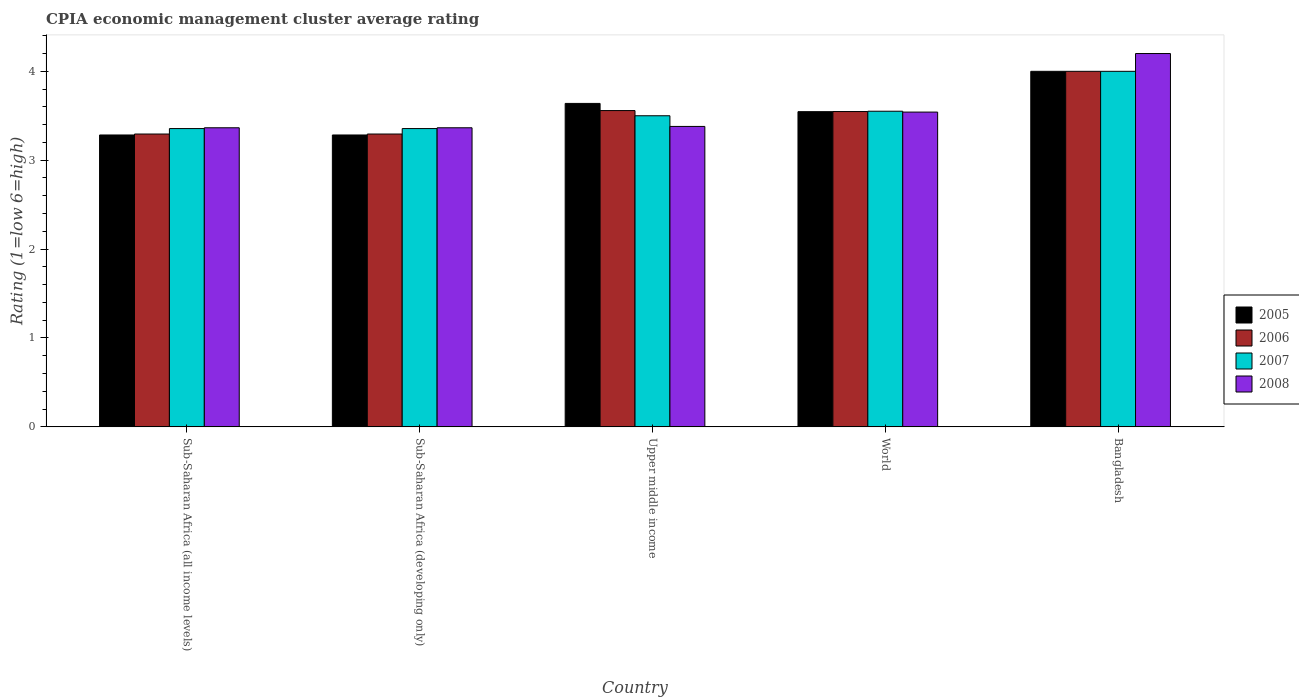How many different coloured bars are there?
Your response must be concise. 4. How many groups of bars are there?
Provide a short and direct response. 5. Are the number of bars per tick equal to the number of legend labels?
Your response must be concise. Yes. What is the CPIA rating in 2006 in Sub-Saharan Africa (developing only)?
Your answer should be compact. 3.29. Across all countries, what is the minimum CPIA rating in 2005?
Offer a very short reply. 3.28. In which country was the CPIA rating in 2007 minimum?
Give a very brief answer. Sub-Saharan Africa (all income levels). What is the total CPIA rating in 2005 in the graph?
Your answer should be compact. 17.75. What is the difference between the CPIA rating in 2005 in Sub-Saharan Africa (all income levels) and that in Upper middle income?
Provide a succinct answer. -0.36. What is the difference between the CPIA rating in 2008 in World and the CPIA rating in 2005 in Bangladesh?
Give a very brief answer. -0.46. What is the average CPIA rating in 2005 per country?
Provide a short and direct response. 3.55. In how many countries, is the CPIA rating in 2007 greater than 4.2?
Offer a terse response. 0. What is the ratio of the CPIA rating in 2005 in Sub-Saharan Africa (developing only) to that in Upper middle income?
Your answer should be very brief. 0.9. Is the CPIA rating in 2007 in Sub-Saharan Africa (all income levels) less than that in Sub-Saharan Africa (developing only)?
Make the answer very short. No. What is the difference between the highest and the second highest CPIA rating in 2008?
Provide a succinct answer. -0.16. What is the difference between the highest and the lowest CPIA rating in 2006?
Your answer should be compact. 0.71. In how many countries, is the CPIA rating in 2007 greater than the average CPIA rating in 2007 taken over all countries?
Your response must be concise. 1. Is it the case that in every country, the sum of the CPIA rating in 2005 and CPIA rating in 2007 is greater than the sum of CPIA rating in 2006 and CPIA rating in 2008?
Offer a very short reply. No. What does the 3rd bar from the right in Bangladesh represents?
Provide a short and direct response. 2006. How many bars are there?
Offer a terse response. 20. Are all the bars in the graph horizontal?
Provide a succinct answer. No. How many countries are there in the graph?
Offer a very short reply. 5. What is the difference between two consecutive major ticks on the Y-axis?
Make the answer very short. 1. Are the values on the major ticks of Y-axis written in scientific E-notation?
Offer a terse response. No. Does the graph contain any zero values?
Your response must be concise. No. Where does the legend appear in the graph?
Make the answer very short. Center right. How many legend labels are there?
Provide a short and direct response. 4. What is the title of the graph?
Ensure brevity in your answer.  CPIA economic management cluster average rating. What is the label or title of the Y-axis?
Provide a succinct answer. Rating (1=low 6=high). What is the Rating (1=low 6=high) in 2005 in Sub-Saharan Africa (all income levels)?
Offer a very short reply. 3.28. What is the Rating (1=low 6=high) in 2006 in Sub-Saharan Africa (all income levels)?
Provide a succinct answer. 3.29. What is the Rating (1=low 6=high) of 2007 in Sub-Saharan Africa (all income levels)?
Provide a short and direct response. 3.36. What is the Rating (1=low 6=high) in 2008 in Sub-Saharan Africa (all income levels)?
Your answer should be very brief. 3.36. What is the Rating (1=low 6=high) in 2005 in Sub-Saharan Africa (developing only)?
Make the answer very short. 3.28. What is the Rating (1=low 6=high) in 2006 in Sub-Saharan Africa (developing only)?
Make the answer very short. 3.29. What is the Rating (1=low 6=high) in 2007 in Sub-Saharan Africa (developing only)?
Ensure brevity in your answer.  3.36. What is the Rating (1=low 6=high) in 2008 in Sub-Saharan Africa (developing only)?
Offer a terse response. 3.36. What is the Rating (1=low 6=high) in 2005 in Upper middle income?
Provide a short and direct response. 3.64. What is the Rating (1=low 6=high) of 2006 in Upper middle income?
Ensure brevity in your answer.  3.56. What is the Rating (1=low 6=high) of 2008 in Upper middle income?
Give a very brief answer. 3.38. What is the Rating (1=low 6=high) of 2005 in World?
Ensure brevity in your answer.  3.55. What is the Rating (1=low 6=high) in 2006 in World?
Provide a succinct answer. 3.55. What is the Rating (1=low 6=high) of 2007 in World?
Ensure brevity in your answer.  3.55. What is the Rating (1=low 6=high) in 2008 in World?
Your response must be concise. 3.54. Across all countries, what is the maximum Rating (1=low 6=high) of 2005?
Ensure brevity in your answer.  4. Across all countries, what is the maximum Rating (1=low 6=high) in 2007?
Offer a very short reply. 4. Across all countries, what is the minimum Rating (1=low 6=high) of 2005?
Offer a very short reply. 3.28. Across all countries, what is the minimum Rating (1=low 6=high) of 2006?
Offer a terse response. 3.29. Across all countries, what is the minimum Rating (1=low 6=high) in 2007?
Provide a succinct answer. 3.36. Across all countries, what is the minimum Rating (1=low 6=high) in 2008?
Keep it short and to the point. 3.36. What is the total Rating (1=low 6=high) in 2005 in the graph?
Provide a short and direct response. 17.75. What is the total Rating (1=low 6=high) in 2006 in the graph?
Give a very brief answer. 17.7. What is the total Rating (1=low 6=high) of 2007 in the graph?
Your answer should be very brief. 17.76. What is the total Rating (1=low 6=high) of 2008 in the graph?
Offer a very short reply. 17.85. What is the difference between the Rating (1=low 6=high) of 2006 in Sub-Saharan Africa (all income levels) and that in Sub-Saharan Africa (developing only)?
Keep it short and to the point. 0. What is the difference between the Rating (1=low 6=high) of 2008 in Sub-Saharan Africa (all income levels) and that in Sub-Saharan Africa (developing only)?
Offer a terse response. 0. What is the difference between the Rating (1=low 6=high) in 2005 in Sub-Saharan Africa (all income levels) and that in Upper middle income?
Provide a short and direct response. -0.36. What is the difference between the Rating (1=low 6=high) in 2006 in Sub-Saharan Africa (all income levels) and that in Upper middle income?
Your answer should be very brief. -0.26. What is the difference between the Rating (1=low 6=high) of 2007 in Sub-Saharan Africa (all income levels) and that in Upper middle income?
Ensure brevity in your answer.  -0.14. What is the difference between the Rating (1=low 6=high) in 2008 in Sub-Saharan Africa (all income levels) and that in Upper middle income?
Your answer should be compact. -0.02. What is the difference between the Rating (1=low 6=high) of 2005 in Sub-Saharan Africa (all income levels) and that in World?
Give a very brief answer. -0.26. What is the difference between the Rating (1=low 6=high) of 2006 in Sub-Saharan Africa (all income levels) and that in World?
Your answer should be compact. -0.25. What is the difference between the Rating (1=low 6=high) of 2007 in Sub-Saharan Africa (all income levels) and that in World?
Keep it short and to the point. -0.2. What is the difference between the Rating (1=low 6=high) in 2008 in Sub-Saharan Africa (all income levels) and that in World?
Ensure brevity in your answer.  -0.18. What is the difference between the Rating (1=low 6=high) in 2005 in Sub-Saharan Africa (all income levels) and that in Bangladesh?
Provide a short and direct response. -0.72. What is the difference between the Rating (1=low 6=high) in 2006 in Sub-Saharan Africa (all income levels) and that in Bangladesh?
Give a very brief answer. -0.71. What is the difference between the Rating (1=low 6=high) in 2007 in Sub-Saharan Africa (all income levels) and that in Bangladesh?
Your response must be concise. -0.64. What is the difference between the Rating (1=low 6=high) in 2008 in Sub-Saharan Africa (all income levels) and that in Bangladesh?
Offer a very short reply. -0.84. What is the difference between the Rating (1=low 6=high) in 2005 in Sub-Saharan Africa (developing only) and that in Upper middle income?
Provide a short and direct response. -0.36. What is the difference between the Rating (1=low 6=high) in 2006 in Sub-Saharan Africa (developing only) and that in Upper middle income?
Give a very brief answer. -0.26. What is the difference between the Rating (1=low 6=high) in 2007 in Sub-Saharan Africa (developing only) and that in Upper middle income?
Make the answer very short. -0.14. What is the difference between the Rating (1=low 6=high) of 2008 in Sub-Saharan Africa (developing only) and that in Upper middle income?
Give a very brief answer. -0.02. What is the difference between the Rating (1=low 6=high) in 2005 in Sub-Saharan Africa (developing only) and that in World?
Make the answer very short. -0.26. What is the difference between the Rating (1=low 6=high) of 2006 in Sub-Saharan Africa (developing only) and that in World?
Offer a very short reply. -0.25. What is the difference between the Rating (1=low 6=high) in 2007 in Sub-Saharan Africa (developing only) and that in World?
Provide a short and direct response. -0.2. What is the difference between the Rating (1=low 6=high) in 2008 in Sub-Saharan Africa (developing only) and that in World?
Provide a short and direct response. -0.18. What is the difference between the Rating (1=low 6=high) in 2005 in Sub-Saharan Africa (developing only) and that in Bangladesh?
Give a very brief answer. -0.72. What is the difference between the Rating (1=low 6=high) in 2006 in Sub-Saharan Africa (developing only) and that in Bangladesh?
Give a very brief answer. -0.71. What is the difference between the Rating (1=low 6=high) in 2007 in Sub-Saharan Africa (developing only) and that in Bangladesh?
Offer a very short reply. -0.64. What is the difference between the Rating (1=low 6=high) in 2008 in Sub-Saharan Africa (developing only) and that in Bangladesh?
Give a very brief answer. -0.84. What is the difference between the Rating (1=low 6=high) in 2005 in Upper middle income and that in World?
Offer a terse response. 0.09. What is the difference between the Rating (1=low 6=high) of 2006 in Upper middle income and that in World?
Your answer should be very brief. 0.01. What is the difference between the Rating (1=low 6=high) in 2007 in Upper middle income and that in World?
Your response must be concise. -0.05. What is the difference between the Rating (1=low 6=high) in 2008 in Upper middle income and that in World?
Make the answer very short. -0.16. What is the difference between the Rating (1=low 6=high) of 2005 in Upper middle income and that in Bangladesh?
Your response must be concise. -0.36. What is the difference between the Rating (1=low 6=high) of 2006 in Upper middle income and that in Bangladesh?
Give a very brief answer. -0.44. What is the difference between the Rating (1=low 6=high) in 2008 in Upper middle income and that in Bangladesh?
Ensure brevity in your answer.  -0.82. What is the difference between the Rating (1=low 6=high) in 2005 in World and that in Bangladesh?
Provide a short and direct response. -0.45. What is the difference between the Rating (1=low 6=high) of 2006 in World and that in Bangladesh?
Give a very brief answer. -0.45. What is the difference between the Rating (1=low 6=high) of 2007 in World and that in Bangladesh?
Provide a short and direct response. -0.45. What is the difference between the Rating (1=low 6=high) in 2008 in World and that in Bangladesh?
Your response must be concise. -0.66. What is the difference between the Rating (1=low 6=high) in 2005 in Sub-Saharan Africa (all income levels) and the Rating (1=low 6=high) in 2006 in Sub-Saharan Africa (developing only)?
Your answer should be very brief. -0.01. What is the difference between the Rating (1=low 6=high) in 2005 in Sub-Saharan Africa (all income levels) and the Rating (1=low 6=high) in 2007 in Sub-Saharan Africa (developing only)?
Your answer should be very brief. -0.07. What is the difference between the Rating (1=low 6=high) in 2005 in Sub-Saharan Africa (all income levels) and the Rating (1=low 6=high) in 2008 in Sub-Saharan Africa (developing only)?
Your response must be concise. -0.08. What is the difference between the Rating (1=low 6=high) in 2006 in Sub-Saharan Africa (all income levels) and the Rating (1=low 6=high) in 2007 in Sub-Saharan Africa (developing only)?
Give a very brief answer. -0.06. What is the difference between the Rating (1=low 6=high) in 2006 in Sub-Saharan Africa (all income levels) and the Rating (1=low 6=high) in 2008 in Sub-Saharan Africa (developing only)?
Provide a succinct answer. -0.07. What is the difference between the Rating (1=low 6=high) of 2007 in Sub-Saharan Africa (all income levels) and the Rating (1=low 6=high) of 2008 in Sub-Saharan Africa (developing only)?
Make the answer very short. -0.01. What is the difference between the Rating (1=low 6=high) of 2005 in Sub-Saharan Africa (all income levels) and the Rating (1=low 6=high) of 2006 in Upper middle income?
Offer a very short reply. -0.27. What is the difference between the Rating (1=low 6=high) of 2005 in Sub-Saharan Africa (all income levels) and the Rating (1=low 6=high) of 2007 in Upper middle income?
Your response must be concise. -0.22. What is the difference between the Rating (1=low 6=high) of 2005 in Sub-Saharan Africa (all income levels) and the Rating (1=low 6=high) of 2008 in Upper middle income?
Provide a succinct answer. -0.1. What is the difference between the Rating (1=low 6=high) of 2006 in Sub-Saharan Africa (all income levels) and the Rating (1=low 6=high) of 2007 in Upper middle income?
Offer a very short reply. -0.21. What is the difference between the Rating (1=low 6=high) of 2006 in Sub-Saharan Africa (all income levels) and the Rating (1=low 6=high) of 2008 in Upper middle income?
Offer a terse response. -0.09. What is the difference between the Rating (1=low 6=high) in 2007 in Sub-Saharan Africa (all income levels) and the Rating (1=low 6=high) in 2008 in Upper middle income?
Keep it short and to the point. -0.02. What is the difference between the Rating (1=low 6=high) of 2005 in Sub-Saharan Africa (all income levels) and the Rating (1=low 6=high) of 2006 in World?
Your answer should be compact. -0.26. What is the difference between the Rating (1=low 6=high) of 2005 in Sub-Saharan Africa (all income levels) and the Rating (1=low 6=high) of 2007 in World?
Make the answer very short. -0.27. What is the difference between the Rating (1=low 6=high) of 2005 in Sub-Saharan Africa (all income levels) and the Rating (1=low 6=high) of 2008 in World?
Ensure brevity in your answer.  -0.26. What is the difference between the Rating (1=low 6=high) in 2006 in Sub-Saharan Africa (all income levels) and the Rating (1=low 6=high) in 2007 in World?
Ensure brevity in your answer.  -0.26. What is the difference between the Rating (1=low 6=high) in 2006 in Sub-Saharan Africa (all income levels) and the Rating (1=low 6=high) in 2008 in World?
Make the answer very short. -0.25. What is the difference between the Rating (1=low 6=high) of 2007 in Sub-Saharan Africa (all income levels) and the Rating (1=low 6=high) of 2008 in World?
Make the answer very short. -0.19. What is the difference between the Rating (1=low 6=high) in 2005 in Sub-Saharan Africa (all income levels) and the Rating (1=low 6=high) in 2006 in Bangladesh?
Your response must be concise. -0.72. What is the difference between the Rating (1=low 6=high) in 2005 in Sub-Saharan Africa (all income levels) and the Rating (1=low 6=high) in 2007 in Bangladesh?
Your answer should be compact. -0.72. What is the difference between the Rating (1=low 6=high) of 2005 in Sub-Saharan Africa (all income levels) and the Rating (1=low 6=high) of 2008 in Bangladesh?
Keep it short and to the point. -0.92. What is the difference between the Rating (1=low 6=high) in 2006 in Sub-Saharan Africa (all income levels) and the Rating (1=low 6=high) in 2007 in Bangladesh?
Provide a succinct answer. -0.71. What is the difference between the Rating (1=low 6=high) in 2006 in Sub-Saharan Africa (all income levels) and the Rating (1=low 6=high) in 2008 in Bangladesh?
Keep it short and to the point. -0.91. What is the difference between the Rating (1=low 6=high) in 2007 in Sub-Saharan Africa (all income levels) and the Rating (1=low 6=high) in 2008 in Bangladesh?
Keep it short and to the point. -0.84. What is the difference between the Rating (1=low 6=high) in 2005 in Sub-Saharan Africa (developing only) and the Rating (1=low 6=high) in 2006 in Upper middle income?
Ensure brevity in your answer.  -0.27. What is the difference between the Rating (1=low 6=high) in 2005 in Sub-Saharan Africa (developing only) and the Rating (1=low 6=high) in 2007 in Upper middle income?
Give a very brief answer. -0.22. What is the difference between the Rating (1=low 6=high) of 2005 in Sub-Saharan Africa (developing only) and the Rating (1=low 6=high) of 2008 in Upper middle income?
Give a very brief answer. -0.1. What is the difference between the Rating (1=low 6=high) in 2006 in Sub-Saharan Africa (developing only) and the Rating (1=low 6=high) in 2007 in Upper middle income?
Your answer should be compact. -0.21. What is the difference between the Rating (1=low 6=high) in 2006 in Sub-Saharan Africa (developing only) and the Rating (1=low 6=high) in 2008 in Upper middle income?
Your response must be concise. -0.09. What is the difference between the Rating (1=low 6=high) in 2007 in Sub-Saharan Africa (developing only) and the Rating (1=low 6=high) in 2008 in Upper middle income?
Ensure brevity in your answer.  -0.02. What is the difference between the Rating (1=low 6=high) of 2005 in Sub-Saharan Africa (developing only) and the Rating (1=low 6=high) of 2006 in World?
Offer a very short reply. -0.26. What is the difference between the Rating (1=low 6=high) of 2005 in Sub-Saharan Africa (developing only) and the Rating (1=low 6=high) of 2007 in World?
Make the answer very short. -0.27. What is the difference between the Rating (1=low 6=high) in 2005 in Sub-Saharan Africa (developing only) and the Rating (1=low 6=high) in 2008 in World?
Offer a very short reply. -0.26. What is the difference between the Rating (1=low 6=high) in 2006 in Sub-Saharan Africa (developing only) and the Rating (1=low 6=high) in 2007 in World?
Your answer should be very brief. -0.26. What is the difference between the Rating (1=low 6=high) in 2006 in Sub-Saharan Africa (developing only) and the Rating (1=low 6=high) in 2008 in World?
Your response must be concise. -0.25. What is the difference between the Rating (1=low 6=high) of 2007 in Sub-Saharan Africa (developing only) and the Rating (1=low 6=high) of 2008 in World?
Your answer should be compact. -0.19. What is the difference between the Rating (1=low 6=high) in 2005 in Sub-Saharan Africa (developing only) and the Rating (1=low 6=high) in 2006 in Bangladesh?
Offer a very short reply. -0.72. What is the difference between the Rating (1=low 6=high) in 2005 in Sub-Saharan Africa (developing only) and the Rating (1=low 6=high) in 2007 in Bangladesh?
Ensure brevity in your answer.  -0.72. What is the difference between the Rating (1=low 6=high) in 2005 in Sub-Saharan Africa (developing only) and the Rating (1=low 6=high) in 2008 in Bangladesh?
Your answer should be compact. -0.92. What is the difference between the Rating (1=low 6=high) in 2006 in Sub-Saharan Africa (developing only) and the Rating (1=low 6=high) in 2007 in Bangladesh?
Ensure brevity in your answer.  -0.71. What is the difference between the Rating (1=low 6=high) of 2006 in Sub-Saharan Africa (developing only) and the Rating (1=low 6=high) of 2008 in Bangladesh?
Your response must be concise. -0.91. What is the difference between the Rating (1=low 6=high) in 2007 in Sub-Saharan Africa (developing only) and the Rating (1=low 6=high) in 2008 in Bangladesh?
Provide a short and direct response. -0.84. What is the difference between the Rating (1=low 6=high) in 2005 in Upper middle income and the Rating (1=low 6=high) in 2006 in World?
Make the answer very short. 0.09. What is the difference between the Rating (1=low 6=high) in 2005 in Upper middle income and the Rating (1=low 6=high) in 2007 in World?
Offer a very short reply. 0.09. What is the difference between the Rating (1=low 6=high) in 2005 in Upper middle income and the Rating (1=low 6=high) in 2008 in World?
Keep it short and to the point. 0.1. What is the difference between the Rating (1=low 6=high) in 2006 in Upper middle income and the Rating (1=low 6=high) in 2007 in World?
Offer a very short reply. 0.01. What is the difference between the Rating (1=low 6=high) in 2006 in Upper middle income and the Rating (1=low 6=high) in 2008 in World?
Your answer should be compact. 0.02. What is the difference between the Rating (1=low 6=high) in 2007 in Upper middle income and the Rating (1=low 6=high) in 2008 in World?
Ensure brevity in your answer.  -0.04. What is the difference between the Rating (1=low 6=high) of 2005 in Upper middle income and the Rating (1=low 6=high) of 2006 in Bangladesh?
Ensure brevity in your answer.  -0.36. What is the difference between the Rating (1=low 6=high) in 2005 in Upper middle income and the Rating (1=low 6=high) in 2007 in Bangladesh?
Your answer should be very brief. -0.36. What is the difference between the Rating (1=low 6=high) in 2005 in Upper middle income and the Rating (1=low 6=high) in 2008 in Bangladesh?
Keep it short and to the point. -0.56. What is the difference between the Rating (1=low 6=high) in 2006 in Upper middle income and the Rating (1=low 6=high) in 2007 in Bangladesh?
Give a very brief answer. -0.44. What is the difference between the Rating (1=low 6=high) of 2006 in Upper middle income and the Rating (1=low 6=high) of 2008 in Bangladesh?
Your answer should be compact. -0.64. What is the difference between the Rating (1=low 6=high) of 2007 in Upper middle income and the Rating (1=low 6=high) of 2008 in Bangladesh?
Your answer should be compact. -0.7. What is the difference between the Rating (1=low 6=high) in 2005 in World and the Rating (1=low 6=high) in 2006 in Bangladesh?
Your answer should be very brief. -0.45. What is the difference between the Rating (1=low 6=high) of 2005 in World and the Rating (1=low 6=high) of 2007 in Bangladesh?
Your answer should be compact. -0.45. What is the difference between the Rating (1=low 6=high) in 2005 in World and the Rating (1=low 6=high) in 2008 in Bangladesh?
Offer a very short reply. -0.65. What is the difference between the Rating (1=low 6=high) of 2006 in World and the Rating (1=low 6=high) of 2007 in Bangladesh?
Ensure brevity in your answer.  -0.45. What is the difference between the Rating (1=low 6=high) of 2006 in World and the Rating (1=low 6=high) of 2008 in Bangladesh?
Provide a succinct answer. -0.65. What is the difference between the Rating (1=low 6=high) in 2007 in World and the Rating (1=low 6=high) in 2008 in Bangladesh?
Offer a very short reply. -0.65. What is the average Rating (1=low 6=high) in 2005 per country?
Your answer should be compact. 3.55. What is the average Rating (1=low 6=high) of 2006 per country?
Keep it short and to the point. 3.54. What is the average Rating (1=low 6=high) of 2007 per country?
Make the answer very short. 3.55. What is the average Rating (1=low 6=high) of 2008 per country?
Provide a succinct answer. 3.57. What is the difference between the Rating (1=low 6=high) in 2005 and Rating (1=low 6=high) in 2006 in Sub-Saharan Africa (all income levels)?
Make the answer very short. -0.01. What is the difference between the Rating (1=low 6=high) in 2005 and Rating (1=low 6=high) in 2007 in Sub-Saharan Africa (all income levels)?
Give a very brief answer. -0.07. What is the difference between the Rating (1=low 6=high) of 2005 and Rating (1=low 6=high) of 2008 in Sub-Saharan Africa (all income levels)?
Provide a short and direct response. -0.08. What is the difference between the Rating (1=low 6=high) of 2006 and Rating (1=low 6=high) of 2007 in Sub-Saharan Africa (all income levels)?
Keep it short and to the point. -0.06. What is the difference between the Rating (1=low 6=high) in 2006 and Rating (1=low 6=high) in 2008 in Sub-Saharan Africa (all income levels)?
Provide a succinct answer. -0.07. What is the difference between the Rating (1=low 6=high) of 2007 and Rating (1=low 6=high) of 2008 in Sub-Saharan Africa (all income levels)?
Your answer should be very brief. -0.01. What is the difference between the Rating (1=low 6=high) of 2005 and Rating (1=low 6=high) of 2006 in Sub-Saharan Africa (developing only)?
Provide a succinct answer. -0.01. What is the difference between the Rating (1=low 6=high) in 2005 and Rating (1=low 6=high) in 2007 in Sub-Saharan Africa (developing only)?
Provide a short and direct response. -0.07. What is the difference between the Rating (1=low 6=high) in 2005 and Rating (1=low 6=high) in 2008 in Sub-Saharan Africa (developing only)?
Give a very brief answer. -0.08. What is the difference between the Rating (1=low 6=high) of 2006 and Rating (1=low 6=high) of 2007 in Sub-Saharan Africa (developing only)?
Offer a very short reply. -0.06. What is the difference between the Rating (1=low 6=high) of 2006 and Rating (1=low 6=high) of 2008 in Sub-Saharan Africa (developing only)?
Make the answer very short. -0.07. What is the difference between the Rating (1=low 6=high) of 2007 and Rating (1=low 6=high) of 2008 in Sub-Saharan Africa (developing only)?
Your response must be concise. -0.01. What is the difference between the Rating (1=low 6=high) of 2005 and Rating (1=low 6=high) of 2006 in Upper middle income?
Provide a short and direct response. 0.08. What is the difference between the Rating (1=low 6=high) in 2005 and Rating (1=low 6=high) in 2007 in Upper middle income?
Provide a short and direct response. 0.14. What is the difference between the Rating (1=low 6=high) in 2005 and Rating (1=low 6=high) in 2008 in Upper middle income?
Your answer should be compact. 0.26. What is the difference between the Rating (1=low 6=high) of 2006 and Rating (1=low 6=high) of 2007 in Upper middle income?
Ensure brevity in your answer.  0.06. What is the difference between the Rating (1=low 6=high) in 2006 and Rating (1=low 6=high) in 2008 in Upper middle income?
Make the answer very short. 0.18. What is the difference between the Rating (1=low 6=high) of 2007 and Rating (1=low 6=high) of 2008 in Upper middle income?
Offer a very short reply. 0.12. What is the difference between the Rating (1=low 6=high) in 2005 and Rating (1=low 6=high) in 2006 in World?
Offer a very short reply. -0. What is the difference between the Rating (1=low 6=high) of 2005 and Rating (1=low 6=high) of 2007 in World?
Provide a short and direct response. -0.01. What is the difference between the Rating (1=low 6=high) of 2005 and Rating (1=low 6=high) of 2008 in World?
Your answer should be compact. 0. What is the difference between the Rating (1=low 6=high) in 2006 and Rating (1=low 6=high) in 2007 in World?
Your response must be concise. -0. What is the difference between the Rating (1=low 6=high) in 2006 and Rating (1=low 6=high) in 2008 in World?
Provide a short and direct response. 0.01. What is the difference between the Rating (1=low 6=high) of 2007 and Rating (1=low 6=high) of 2008 in World?
Keep it short and to the point. 0.01. What is the difference between the Rating (1=low 6=high) of 2005 and Rating (1=low 6=high) of 2008 in Bangladesh?
Your response must be concise. -0.2. What is the difference between the Rating (1=low 6=high) in 2006 and Rating (1=low 6=high) in 2008 in Bangladesh?
Keep it short and to the point. -0.2. What is the ratio of the Rating (1=low 6=high) in 2005 in Sub-Saharan Africa (all income levels) to that in Sub-Saharan Africa (developing only)?
Make the answer very short. 1. What is the ratio of the Rating (1=low 6=high) of 2007 in Sub-Saharan Africa (all income levels) to that in Sub-Saharan Africa (developing only)?
Make the answer very short. 1. What is the ratio of the Rating (1=low 6=high) in 2005 in Sub-Saharan Africa (all income levels) to that in Upper middle income?
Your answer should be very brief. 0.9. What is the ratio of the Rating (1=low 6=high) in 2006 in Sub-Saharan Africa (all income levels) to that in Upper middle income?
Make the answer very short. 0.93. What is the ratio of the Rating (1=low 6=high) of 2007 in Sub-Saharan Africa (all income levels) to that in Upper middle income?
Provide a short and direct response. 0.96. What is the ratio of the Rating (1=low 6=high) in 2008 in Sub-Saharan Africa (all income levels) to that in Upper middle income?
Ensure brevity in your answer.  1. What is the ratio of the Rating (1=low 6=high) of 2005 in Sub-Saharan Africa (all income levels) to that in World?
Provide a succinct answer. 0.93. What is the ratio of the Rating (1=low 6=high) in 2006 in Sub-Saharan Africa (all income levels) to that in World?
Offer a terse response. 0.93. What is the ratio of the Rating (1=low 6=high) of 2007 in Sub-Saharan Africa (all income levels) to that in World?
Provide a short and direct response. 0.94. What is the ratio of the Rating (1=low 6=high) in 2008 in Sub-Saharan Africa (all income levels) to that in World?
Offer a very short reply. 0.95. What is the ratio of the Rating (1=low 6=high) of 2005 in Sub-Saharan Africa (all income levels) to that in Bangladesh?
Give a very brief answer. 0.82. What is the ratio of the Rating (1=low 6=high) in 2006 in Sub-Saharan Africa (all income levels) to that in Bangladesh?
Your answer should be compact. 0.82. What is the ratio of the Rating (1=low 6=high) of 2007 in Sub-Saharan Africa (all income levels) to that in Bangladesh?
Ensure brevity in your answer.  0.84. What is the ratio of the Rating (1=low 6=high) of 2008 in Sub-Saharan Africa (all income levels) to that in Bangladesh?
Provide a succinct answer. 0.8. What is the ratio of the Rating (1=low 6=high) in 2005 in Sub-Saharan Africa (developing only) to that in Upper middle income?
Your response must be concise. 0.9. What is the ratio of the Rating (1=low 6=high) in 2006 in Sub-Saharan Africa (developing only) to that in Upper middle income?
Provide a short and direct response. 0.93. What is the ratio of the Rating (1=low 6=high) of 2007 in Sub-Saharan Africa (developing only) to that in Upper middle income?
Offer a terse response. 0.96. What is the ratio of the Rating (1=low 6=high) in 2005 in Sub-Saharan Africa (developing only) to that in World?
Give a very brief answer. 0.93. What is the ratio of the Rating (1=low 6=high) of 2006 in Sub-Saharan Africa (developing only) to that in World?
Keep it short and to the point. 0.93. What is the ratio of the Rating (1=low 6=high) of 2007 in Sub-Saharan Africa (developing only) to that in World?
Keep it short and to the point. 0.94. What is the ratio of the Rating (1=low 6=high) in 2008 in Sub-Saharan Africa (developing only) to that in World?
Provide a succinct answer. 0.95. What is the ratio of the Rating (1=low 6=high) of 2005 in Sub-Saharan Africa (developing only) to that in Bangladesh?
Your response must be concise. 0.82. What is the ratio of the Rating (1=low 6=high) of 2006 in Sub-Saharan Africa (developing only) to that in Bangladesh?
Provide a succinct answer. 0.82. What is the ratio of the Rating (1=low 6=high) in 2007 in Sub-Saharan Africa (developing only) to that in Bangladesh?
Give a very brief answer. 0.84. What is the ratio of the Rating (1=low 6=high) in 2008 in Sub-Saharan Africa (developing only) to that in Bangladesh?
Ensure brevity in your answer.  0.8. What is the ratio of the Rating (1=low 6=high) of 2005 in Upper middle income to that in World?
Your answer should be compact. 1.03. What is the ratio of the Rating (1=low 6=high) of 2007 in Upper middle income to that in World?
Provide a succinct answer. 0.99. What is the ratio of the Rating (1=low 6=high) in 2008 in Upper middle income to that in World?
Your answer should be very brief. 0.95. What is the ratio of the Rating (1=low 6=high) of 2005 in Upper middle income to that in Bangladesh?
Provide a succinct answer. 0.91. What is the ratio of the Rating (1=low 6=high) of 2006 in Upper middle income to that in Bangladesh?
Your answer should be compact. 0.89. What is the ratio of the Rating (1=low 6=high) in 2008 in Upper middle income to that in Bangladesh?
Offer a terse response. 0.8. What is the ratio of the Rating (1=low 6=high) in 2005 in World to that in Bangladesh?
Offer a terse response. 0.89. What is the ratio of the Rating (1=low 6=high) in 2006 in World to that in Bangladesh?
Give a very brief answer. 0.89. What is the ratio of the Rating (1=low 6=high) in 2007 in World to that in Bangladesh?
Make the answer very short. 0.89. What is the ratio of the Rating (1=low 6=high) of 2008 in World to that in Bangladesh?
Ensure brevity in your answer.  0.84. What is the difference between the highest and the second highest Rating (1=low 6=high) of 2005?
Provide a short and direct response. 0.36. What is the difference between the highest and the second highest Rating (1=low 6=high) in 2006?
Provide a succinct answer. 0.44. What is the difference between the highest and the second highest Rating (1=low 6=high) of 2007?
Your answer should be very brief. 0.45. What is the difference between the highest and the second highest Rating (1=low 6=high) in 2008?
Keep it short and to the point. 0.66. What is the difference between the highest and the lowest Rating (1=low 6=high) of 2005?
Ensure brevity in your answer.  0.72. What is the difference between the highest and the lowest Rating (1=low 6=high) of 2006?
Provide a short and direct response. 0.71. What is the difference between the highest and the lowest Rating (1=low 6=high) of 2007?
Offer a terse response. 0.64. What is the difference between the highest and the lowest Rating (1=low 6=high) of 2008?
Keep it short and to the point. 0.84. 